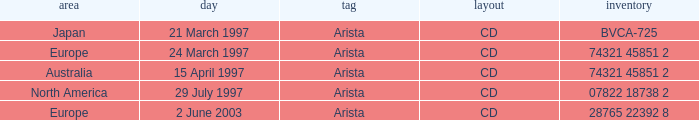Write the full table. {'header': ['area', 'day', 'tag', 'layout', 'inventory'], 'rows': [['Japan', '21 March 1997', 'Arista', 'CD', 'BVCA-725'], ['Europe', '24 March 1997', 'Arista', 'CD', '74321 45851 2'], ['Australia', '15 April 1997', 'Arista', 'CD', '74321 45851 2'], ['North America', '29 July 1997', 'Arista', 'CD', '07822 18738 2'], ['Europe', '2 June 2003', 'Arista', 'CD', '28765 22392 8']]} What's the Date with the Region of Europe and has a Catalog of 28765 22392 8? 2 June 2003. 